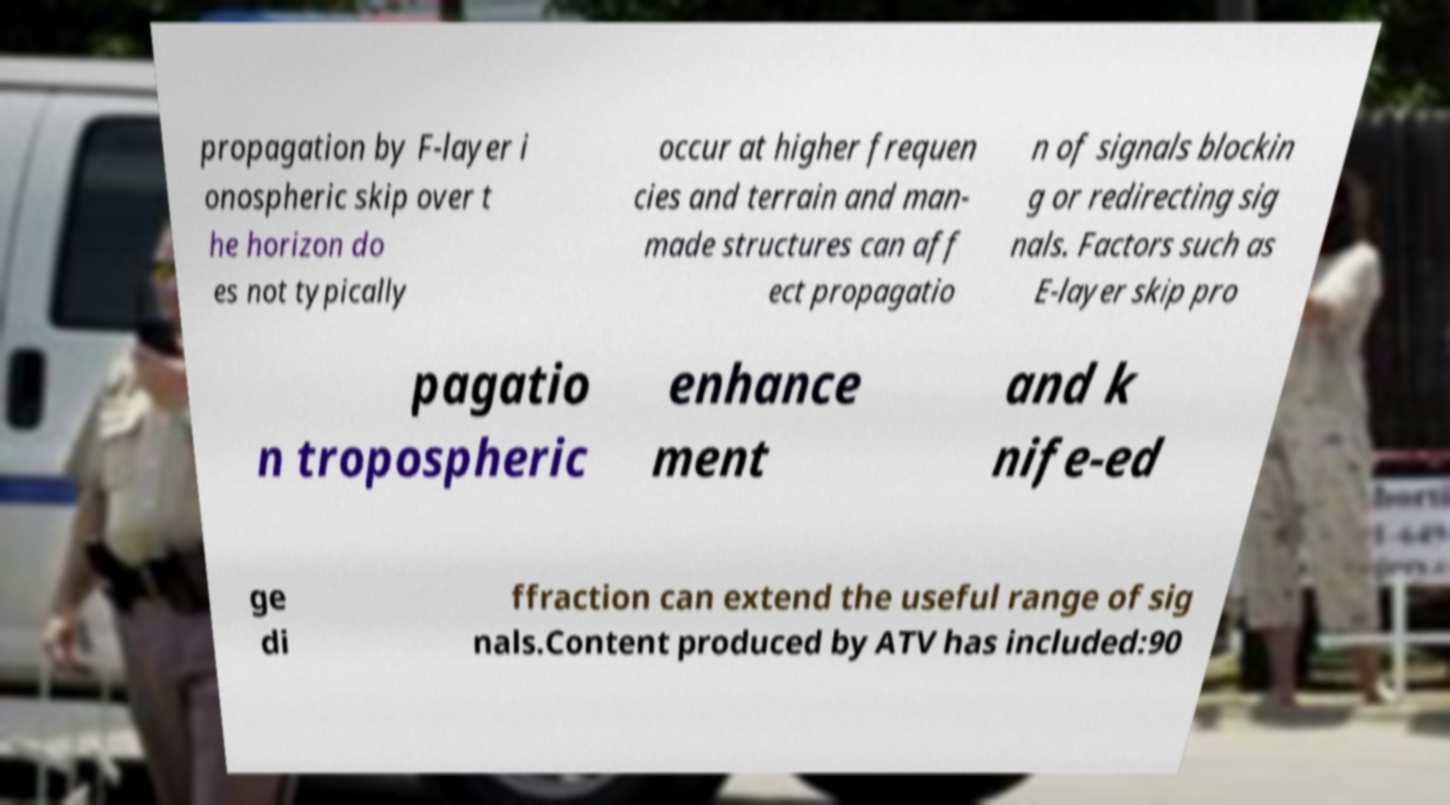Can you accurately transcribe the text from the provided image for me? propagation by F-layer i onospheric skip over t he horizon do es not typically occur at higher frequen cies and terrain and man- made structures can aff ect propagatio n of signals blockin g or redirecting sig nals. Factors such as E-layer skip pro pagatio n tropospheric enhance ment and k nife-ed ge di ffraction can extend the useful range of sig nals.Content produced by ATV has included:90 